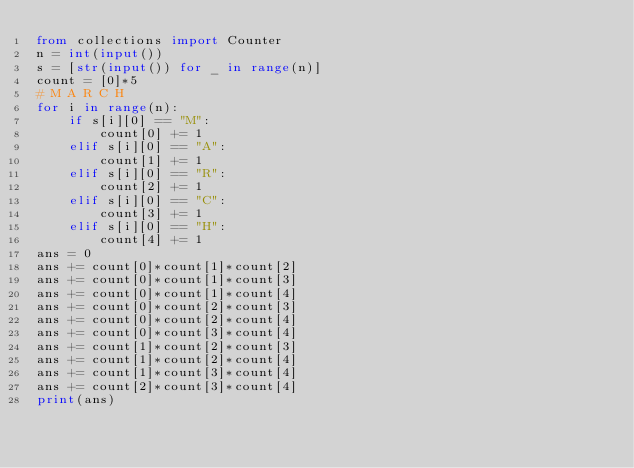<code> <loc_0><loc_0><loc_500><loc_500><_Python_>from collections import Counter
n = int(input())
s = [str(input()) for _ in range(n)]
count = [0]*5
# M A R C H
for i in range(n):
    if s[i][0] == "M":
        count[0] += 1
    elif s[i][0] == "A":
        count[1] += 1
    elif s[i][0] == "R":
        count[2] += 1
    elif s[i][0] == "C":
        count[3] += 1
    elif s[i][0] == "H":
        count[4] += 1
ans = 0
ans += count[0]*count[1]*count[2]
ans += count[0]*count[1]*count[3]
ans += count[0]*count[1]*count[4]
ans += count[0]*count[2]*count[3]
ans += count[0]*count[2]*count[4]
ans += count[0]*count[3]*count[4]
ans += count[1]*count[2]*count[3]
ans += count[1]*count[2]*count[4]
ans += count[1]*count[3]*count[4]
ans += count[2]*count[3]*count[4]
print(ans)</code> 